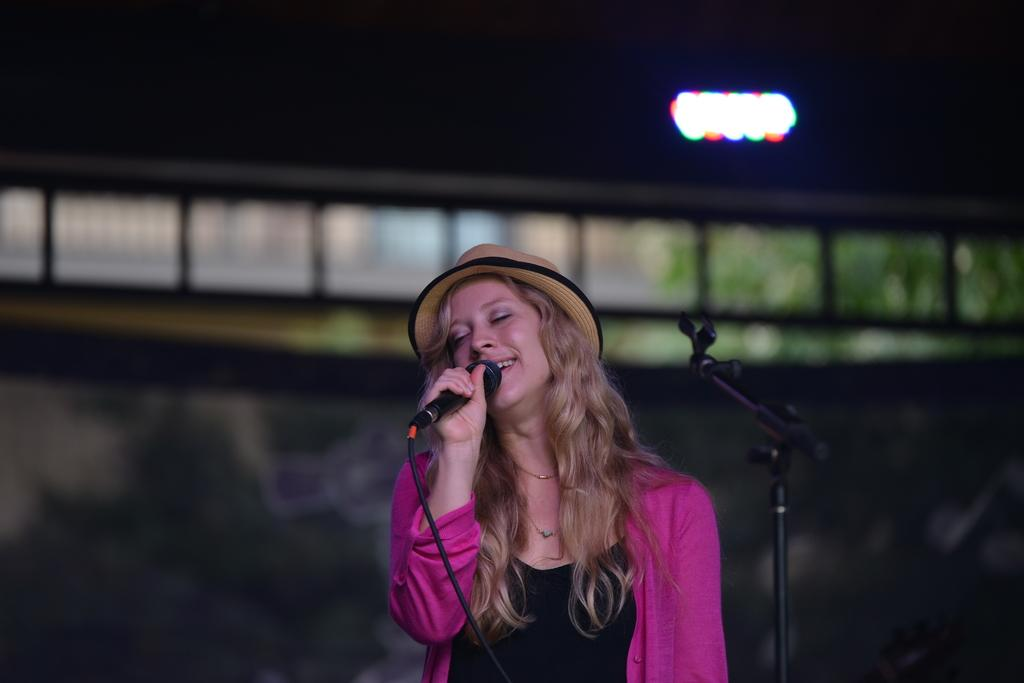Who is the main subject in the image? There is a girl in the image. What is the girl doing in the image? The girl is singing. What object is the girl holding while singing? The girl is holding a microphone. What can be seen in the background of the image? There are lights in the background of the image. What type of flesh can be seen on the girl's neck in the image? There is no flesh visible on the girl's neck in the image. The image does not show any close-up details of the girl's body. 